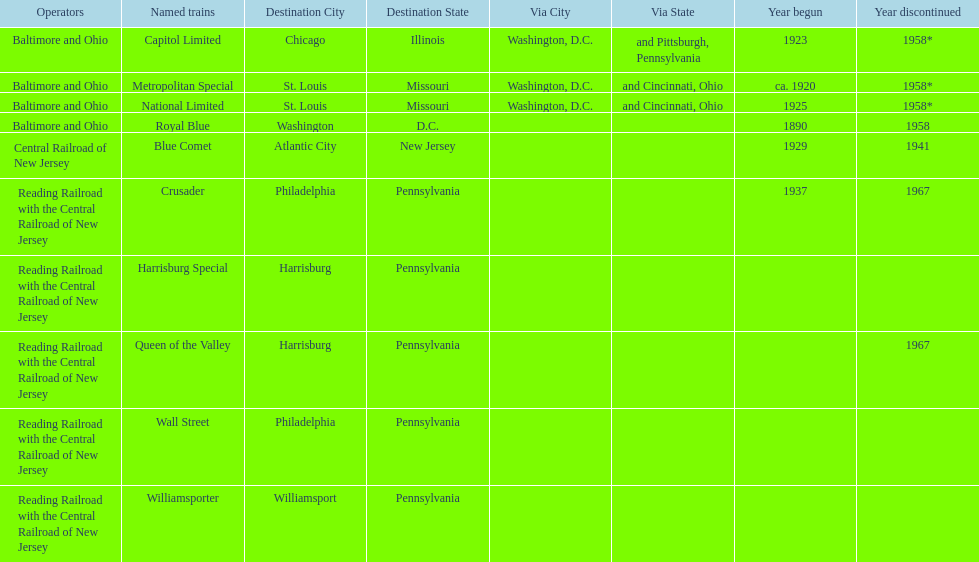What was the first train to begin service? Royal Blue. 